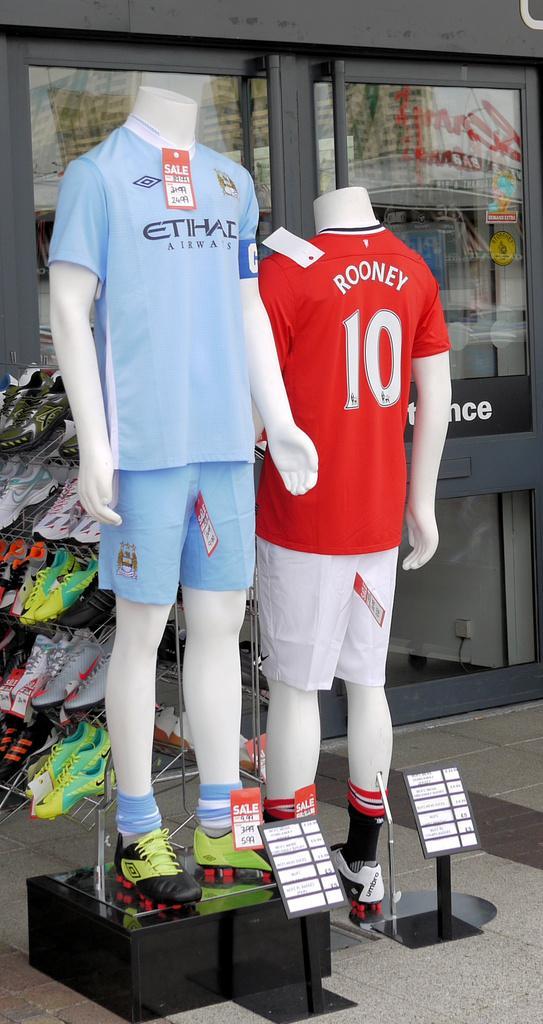Can you describe this image briefly? I can see two mannequins with T-shirts, shorts, socks and shoes. This is the price tag attached to the clothes. These are the boards. I can see few pairs of shoes, which are arranged in the rack. This is the glass door. 